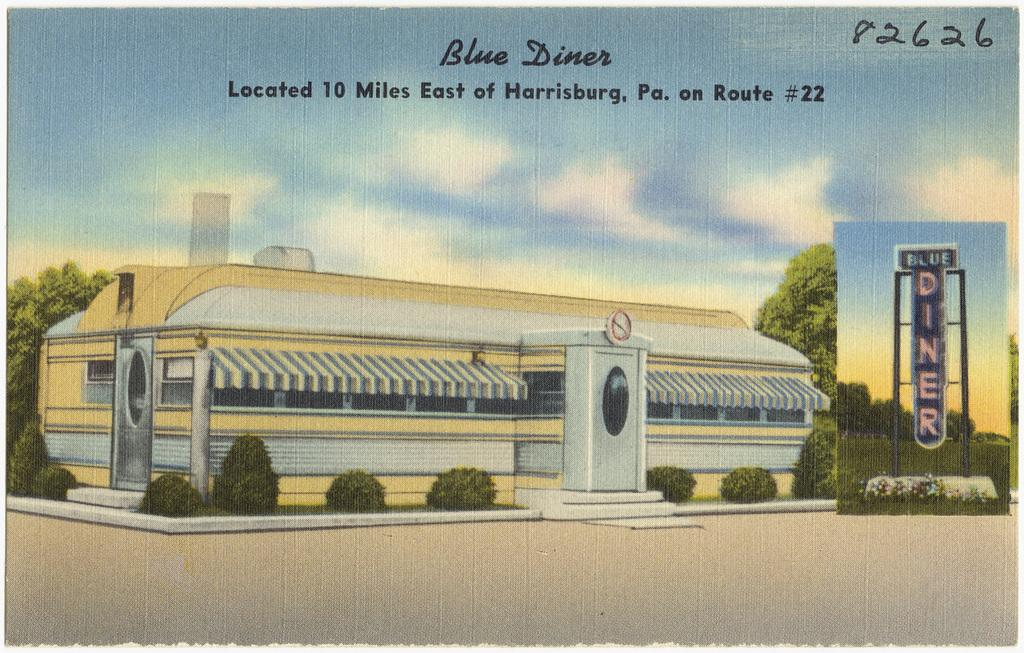<image>
Write a terse but informative summary of the picture. A post card of the Blue Diner in Harrisburg, PA. 